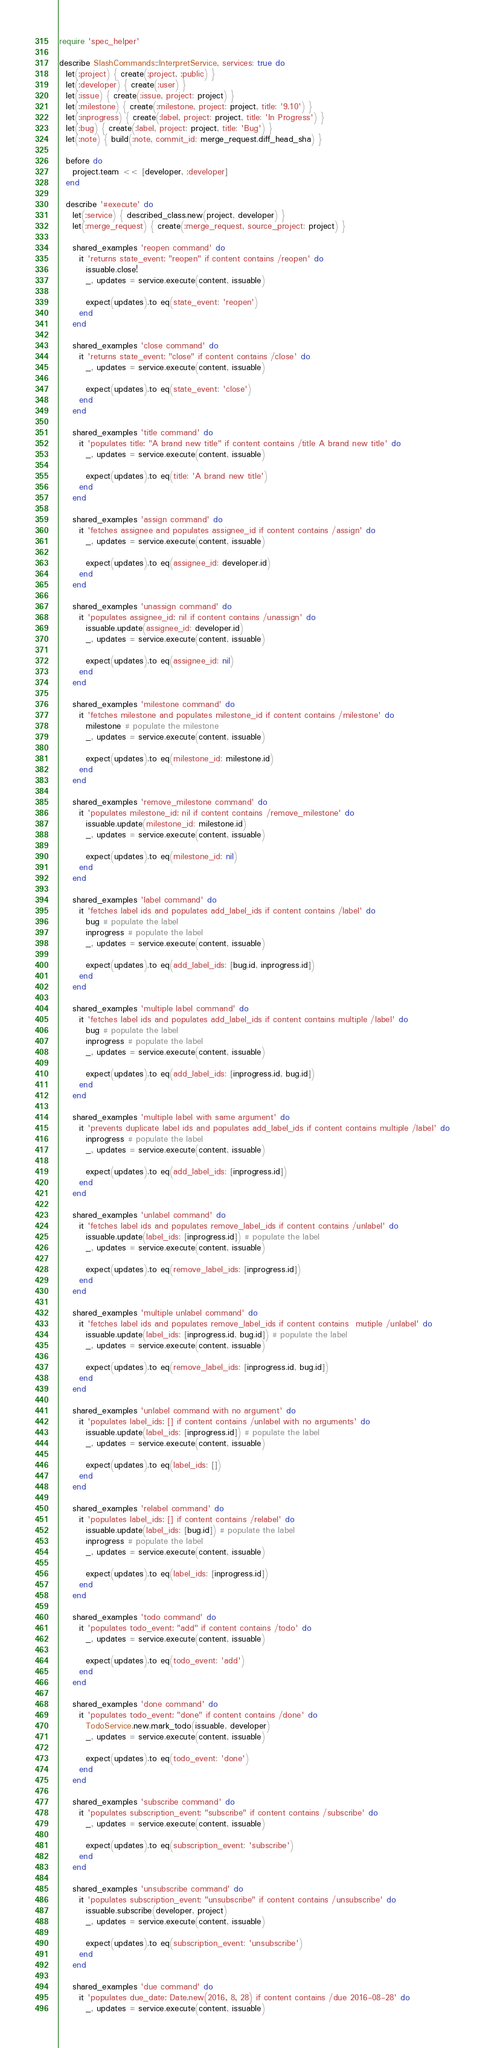Convert code to text. <code><loc_0><loc_0><loc_500><loc_500><_Ruby_>require 'spec_helper'

describe SlashCommands::InterpretService, services: true do
  let(:project) { create(:project, :public) }
  let(:developer) { create(:user) }
  let(:issue) { create(:issue, project: project) }
  let(:milestone) { create(:milestone, project: project, title: '9.10') }
  let(:inprogress) { create(:label, project: project, title: 'In Progress') }
  let(:bug) { create(:label, project: project, title: 'Bug') }
  let(:note) { build(:note, commit_id: merge_request.diff_head_sha) }

  before do
    project.team << [developer, :developer]
  end

  describe '#execute' do
    let(:service) { described_class.new(project, developer) }
    let(:merge_request) { create(:merge_request, source_project: project) }

    shared_examples 'reopen command' do
      it 'returns state_event: "reopen" if content contains /reopen' do
        issuable.close!
        _, updates = service.execute(content, issuable)

        expect(updates).to eq(state_event: 'reopen')
      end
    end

    shared_examples 'close command' do
      it 'returns state_event: "close" if content contains /close' do
        _, updates = service.execute(content, issuable)

        expect(updates).to eq(state_event: 'close')
      end
    end

    shared_examples 'title command' do
      it 'populates title: "A brand new title" if content contains /title A brand new title' do
        _, updates = service.execute(content, issuable)

        expect(updates).to eq(title: 'A brand new title')
      end
    end

    shared_examples 'assign command' do
      it 'fetches assignee and populates assignee_id if content contains /assign' do
        _, updates = service.execute(content, issuable)

        expect(updates).to eq(assignee_id: developer.id)
      end
    end

    shared_examples 'unassign command' do
      it 'populates assignee_id: nil if content contains /unassign' do
        issuable.update(assignee_id: developer.id)
        _, updates = service.execute(content, issuable)

        expect(updates).to eq(assignee_id: nil)
      end
    end

    shared_examples 'milestone command' do
      it 'fetches milestone and populates milestone_id if content contains /milestone' do
        milestone # populate the milestone
        _, updates = service.execute(content, issuable)

        expect(updates).to eq(milestone_id: milestone.id)
      end
    end

    shared_examples 'remove_milestone command' do
      it 'populates milestone_id: nil if content contains /remove_milestone' do
        issuable.update(milestone_id: milestone.id)
        _, updates = service.execute(content, issuable)

        expect(updates).to eq(milestone_id: nil)
      end
    end

    shared_examples 'label command' do
      it 'fetches label ids and populates add_label_ids if content contains /label' do
        bug # populate the label
        inprogress # populate the label
        _, updates = service.execute(content, issuable)

        expect(updates).to eq(add_label_ids: [bug.id, inprogress.id])
      end
    end

    shared_examples 'multiple label command' do
      it 'fetches label ids and populates add_label_ids if content contains multiple /label' do
        bug # populate the label
        inprogress # populate the label
        _, updates = service.execute(content, issuable)

        expect(updates).to eq(add_label_ids: [inprogress.id, bug.id])
      end
    end

    shared_examples 'multiple label with same argument' do
      it 'prevents duplicate label ids and populates add_label_ids if content contains multiple /label' do
        inprogress # populate the label
        _, updates = service.execute(content, issuable)

        expect(updates).to eq(add_label_ids: [inprogress.id])
      end
    end

    shared_examples 'unlabel command' do
      it 'fetches label ids and populates remove_label_ids if content contains /unlabel' do
        issuable.update(label_ids: [inprogress.id]) # populate the label
        _, updates = service.execute(content, issuable)

        expect(updates).to eq(remove_label_ids: [inprogress.id])
      end
    end

    shared_examples 'multiple unlabel command' do
      it 'fetches label ids and populates remove_label_ids if content contains  mutiple /unlabel' do
        issuable.update(label_ids: [inprogress.id, bug.id]) # populate the label
        _, updates = service.execute(content, issuable)

        expect(updates).to eq(remove_label_ids: [inprogress.id, bug.id])
      end
    end

    shared_examples 'unlabel command with no argument' do
      it 'populates label_ids: [] if content contains /unlabel with no arguments' do
        issuable.update(label_ids: [inprogress.id]) # populate the label
        _, updates = service.execute(content, issuable)

        expect(updates).to eq(label_ids: [])
      end
    end

    shared_examples 'relabel command' do
      it 'populates label_ids: [] if content contains /relabel' do
        issuable.update(label_ids: [bug.id]) # populate the label
        inprogress # populate the label
        _, updates = service.execute(content, issuable)

        expect(updates).to eq(label_ids: [inprogress.id])
      end
    end

    shared_examples 'todo command' do
      it 'populates todo_event: "add" if content contains /todo' do
        _, updates = service.execute(content, issuable)

        expect(updates).to eq(todo_event: 'add')
      end
    end

    shared_examples 'done command' do
      it 'populates todo_event: "done" if content contains /done' do
        TodoService.new.mark_todo(issuable, developer)
        _, updates = service.execute(content, issuable)

        expect(updates).to eq(todo_event: 'done')
      end
    end

    shared_examples 'subscribe command' do
      it 'populates subscription_event: "subscribe" if content contains /subscribe' do
        _, updates = service.execute(content, issuable)

        expect(updates).to eq(subscription_event: 'subscribe')
      end
    end

    shared_examples 'unsubscribe command' do
      it 'populates subscription_event: "unsubscribe" if content contains /unsubscribe' do
        issuable.subscribe(developer, project)
        _, updates = service.execute(content, issuable)

        expect(updates).to eq(subscription_event: 'unsubscribe')
      end
    end

    shared_examples 'due command' do
      it 'populates due_date: Date.new(2016, 8, 28) if content contains /due 2016-08-28' do
        _, updates = service.execute(content, issuable)
</code> 